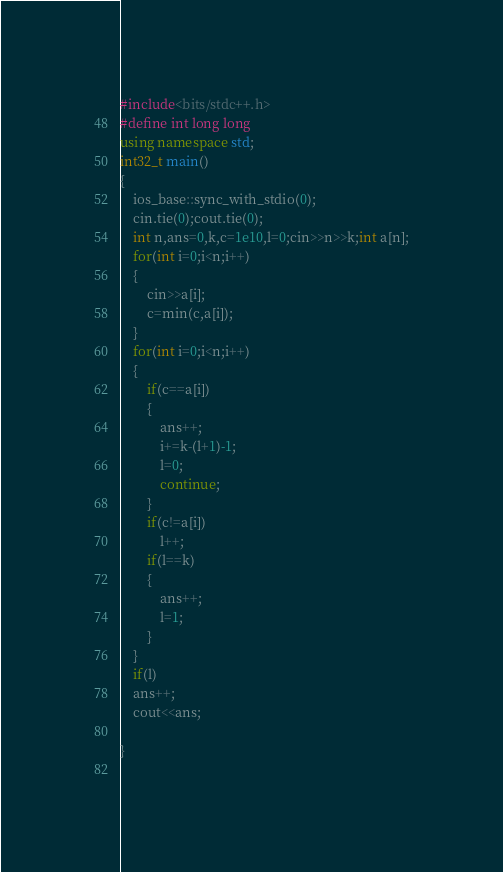<code> <loc_0><loc_0><loc_500><loc_500><_C++_>#include<bits/stdc++.h>
#define int long long
using namespace std;
int32_t main()
{
    ios_base::sync_with_stdio(0);
    cin.tie(0);cout.tie(0);
    int n,ans=0,k,c=1e10,l=0;cin>>n>>k;int a[n];
    for(int i=0;i<n;i++)
    {
        cin>>a[i];
        c=min(c,a[i]);
    }
    for(int i=0;i<n;i++)
    {
        if(c==a[i])
        {
            ans++;
            i+=k-(l+1)-1;
            l=0;
            continue;
        }
        if(c!=a[i])
            l++;
        if(l==k)
        {
            ans++;
            l=1;
        }
    }
    if(l)
    ans++;
    cout<<ans;
    
}
 </code> 